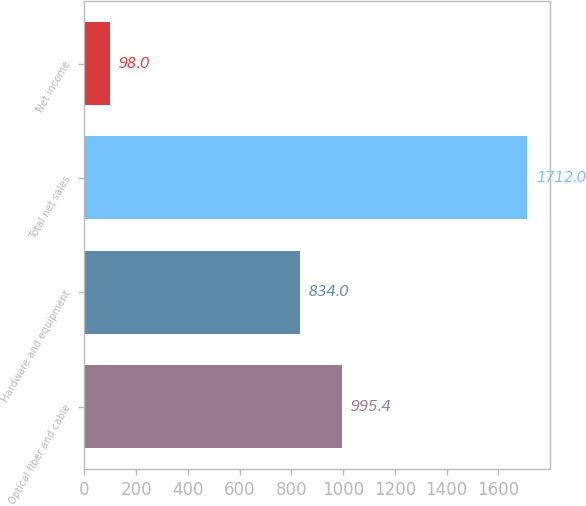<chart> <loc_0><loc_0><loc_500><loc_500><bar_chart><fcel>Optical fiber and cable<fcel>Hardware and equipment<fcel>Total net sales<fcel>Net income<nl><fcel>995.4<fcel>834<fcel>1712<fcel>98<nl></chart> 